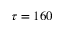Convert formula to latex. <formula><loc_0><loc_0><loc_500><loc_500>\tau = 1 6 0</formula> 